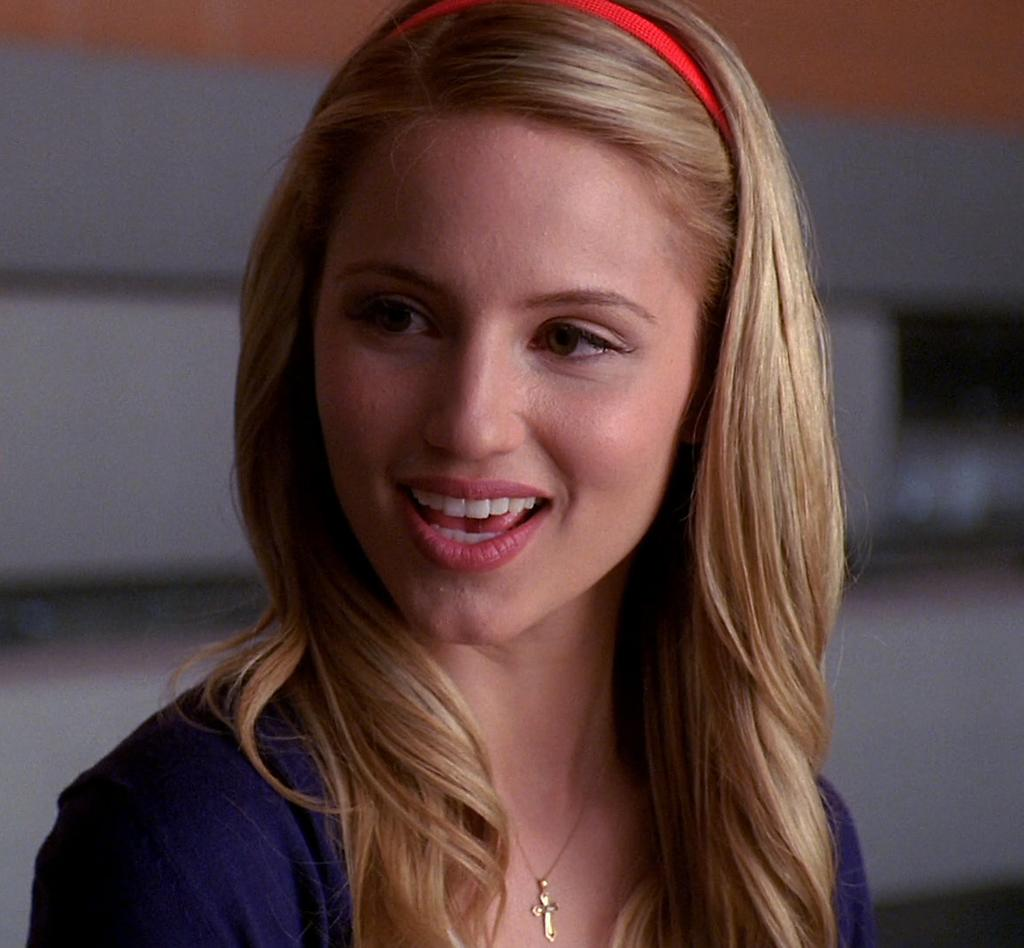Who is the main subject in the foreground of the image? There is a woman in the foreground of the image. What is the woman wearing on her head? The woman is wearing a headband. What is the woman doing in the image? The woman appears to be talking. How would you describe the background of the image? The background of the image is blurry. What type of sack can be seen in the woman's hand in the image? There is no sack visible in the woman's hand in the image. What offer is the woman making to the person she is talking to in the image? The image does not provide any information about an offer being made by the woman. 